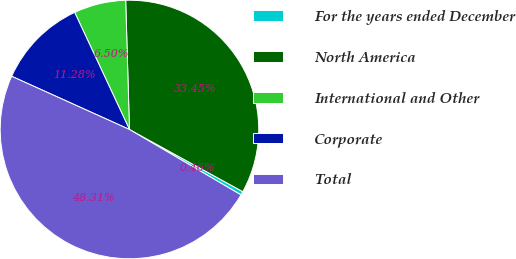Convert chart. <chart><loc_0><loc_0><loc_500><loc_500><pie_chart><fcel>For the years ended December<fcel>North America<fcel>International and Other<fcel>Corporate<fcel>Total<nl><fcel>0.46%<fcel>33.45%<fcel>6.5%<fcel>11.28%<fcel>48.31%<nl></chart> 